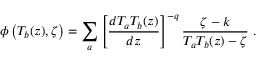<formula> <loc_0><loc_0><loc_500><loc_500>\phi \left ( T _ { b } ( z ) , \zeta \right ) = \sum _ { a } \left [ \frac { d T _ { a } T _ { b } ( z ) } { d z } \right ] ^ { - q } \frac { \zeta - k } { T _ { a } T _ { b } ( z ) - \zeta } \ .</formula> 